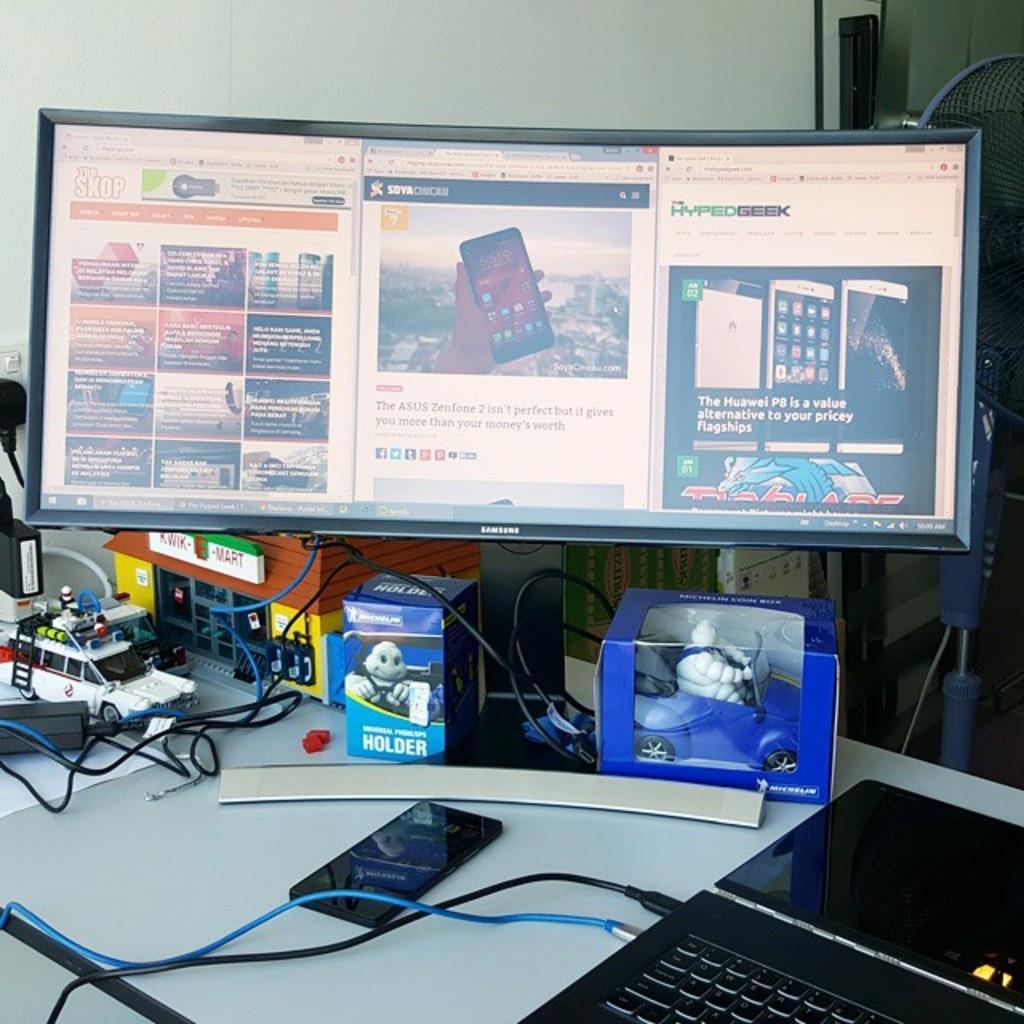Describe this image in one or two sentences. In the picture I can see computer, a laptop, a mobile phone, car toys and cables are kept on the table. I can see a fan on the top right side. 